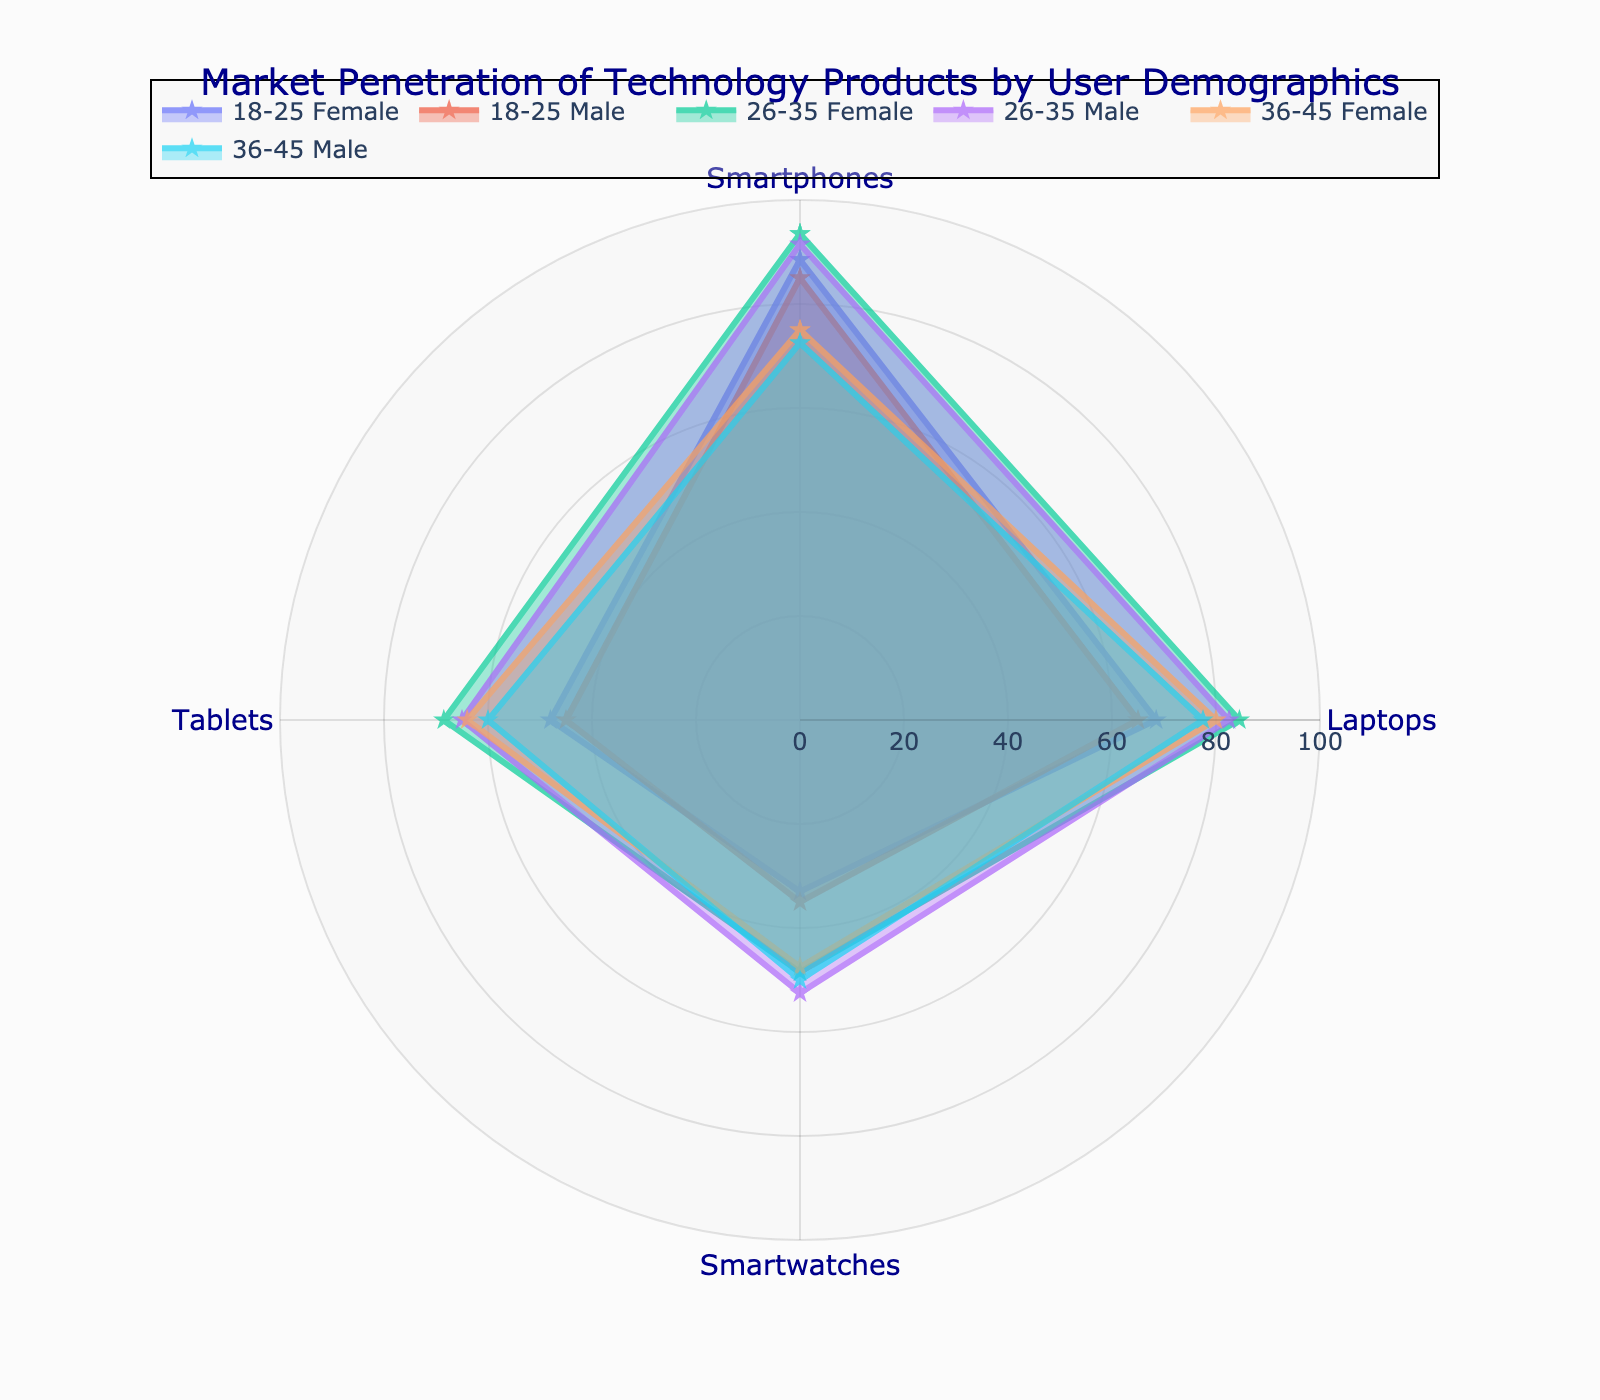What is the title of the plot? The title of the plot is usually displayed at the top of the figure. In this case, it reads "Market Penetration of Technology Products by User Demographics".
Answer: Market Penetration of Technology Products by User Demographics Which user demographic group has the highest usage of smartwatches? The highest usage of smartwatches can be identified by looking at the value for each user demographic group in the Smartwatches category. "26-35 Male High" and "26-35 Female High" groups both have high values, the latter being slightly lower.
Answer: 26-35 Male High 